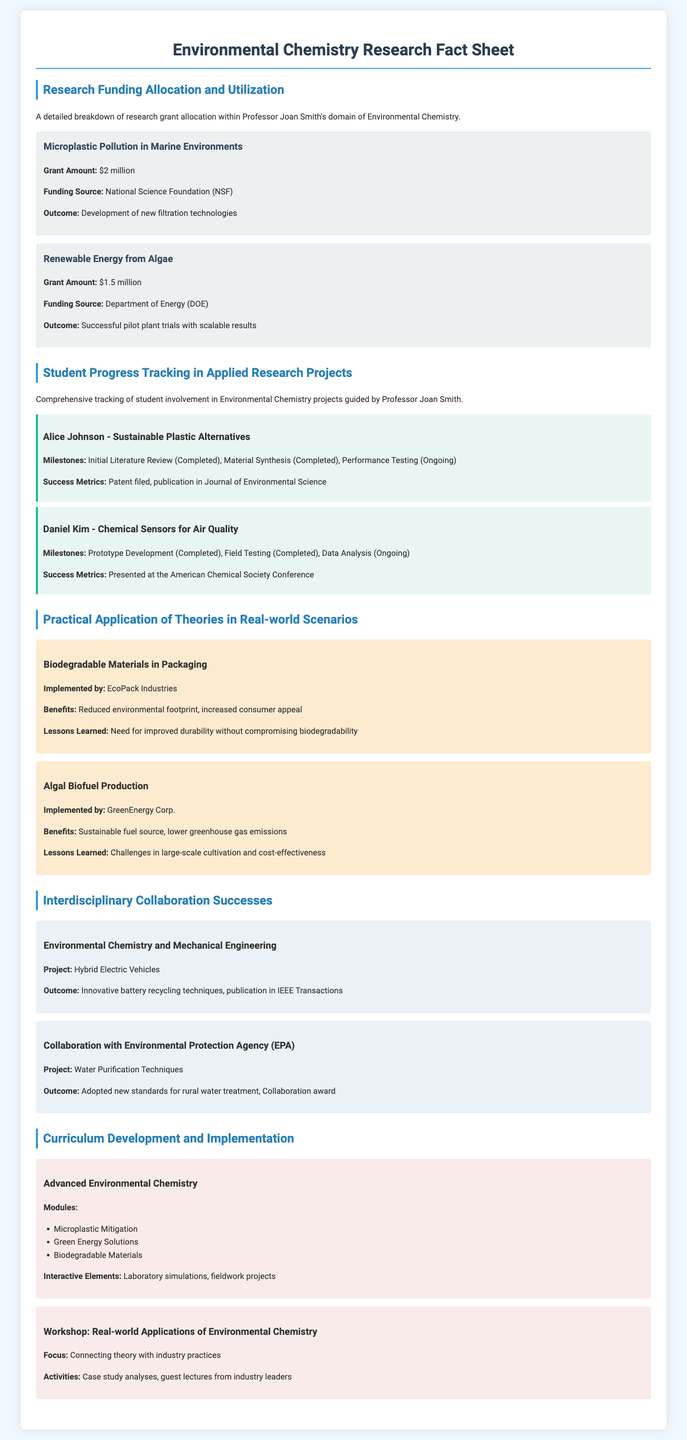What is the grant amount for Microplastic Pollution in Marine Environments? The document states that the grant amount for this project is specifically noted as $2 million.
Answer: $2 million Who is the student working on Sustainable Plastic Alternatives? The document highlights Alice Johnson as the student involved in this applied research project.
Answer: Alice Johnson What are the benefits of Biodegradable Materials in Packaging? The document lists the benefits of this implementation as reduced environmental footprint and increased consumer appeal.
Answer: Reduced environmental footprint, increased consumer appeal Which organizations collaborated on the Water Purification Techniques project? The document indicates that there was a collaboration with the Environmental Protection Agency (EPA) on this project.
Answer: Environmental Protection Agency (EPA) What percentage of the curriculum module in Advanced Environmental Chemistry focuses on Microplastic Mitigation? The document lists Microplastic Mitigation as one of the modules but does not provide a percentage.
Answer: Not provided What was the outcome of the Renewable Energy from Algae project? The document states that the outcome was successful pilot plant trials with scalable results.
Answer: Successful pilot plant trials with scalable results Which industry implemented the case study on Algal Biofuel Production? The document mentions that GreenEnergy Corp. implemented the case study related to algal biofuel production.
Answer: GreenEnergy Corp What interactive element is included in the course Advanced Environmental Chemistry? The document highlights laboratory simulations as one of the interactive elements in this course.
Answer: Laboratory simulations 